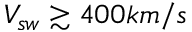<formula> <loc_0><loc_0><loc_500><loc_500>V _ { s w } \gtrsim 4 0 0 k m / s</formula> 